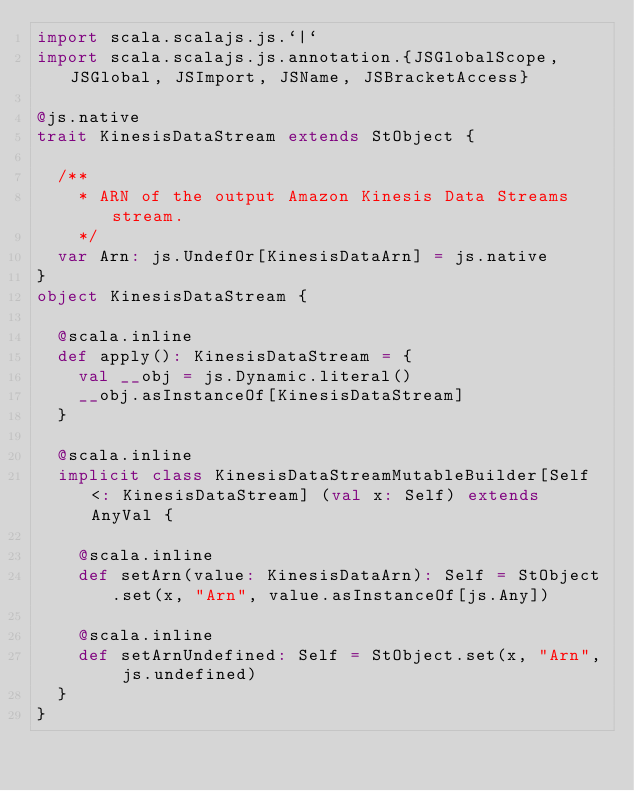<code> <loc_0><loc_0><loc_500><loc_500><_Scala_>import scala.scalajs.js.`|`
import scala.scalajs.js.annotation.{JSGlobalScope, JSGlobal, JSImport, JSName, JSBracketAccess}

@js.native
trait KinesisDataStream extends StObject {
  
  /**
    * ARN of the output Amazon Kinesis Data Streams stream.
    */
  var Arn: js.UndefOr[KinesisDataArn] = js.native
}
object KinesisDataStream {
  
  @scala.inline
  def apply(): KinesisDataStream = {
    val __obj = js.Dynamic.literal()
    __obj.asInstanceOf[KinesisDataStream]
  }
  
  @scala.inline
  implicit class KinesisDataStreamMutableBuilder[Self <: KinesisDataStream] (val x: Self) extends AnyVal {
    
    @scala.inline
    def setArn(value: KinesisDataArn): Self = StObject.set(x, "Arn", value.asInstanceOf[js.Any])
    
    @scala.inline
    def setArnUndefined: Self = StObject.set(x, "Arn", js.undefined)
  }
}
</code> 